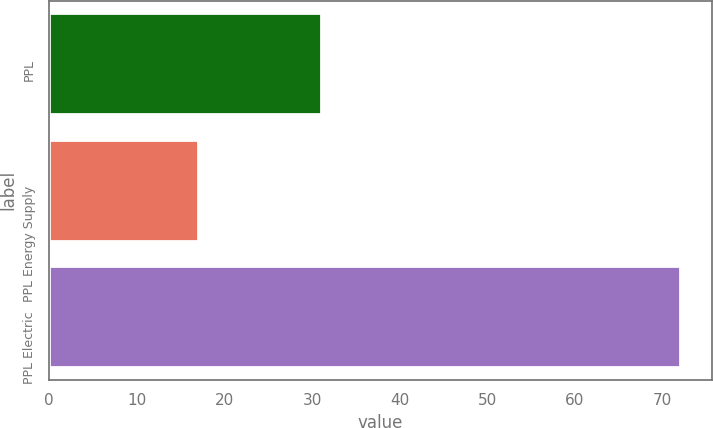Convert chart to OTSL. <chart><loc_0><loc_0><loc_500><loc_500><bar_chart><fcel>PPL<fcel>PPL Energy Supply<fcel>PPL Electric<nl><fcel>31<fcel>17<fcel>72<nl></chart> 